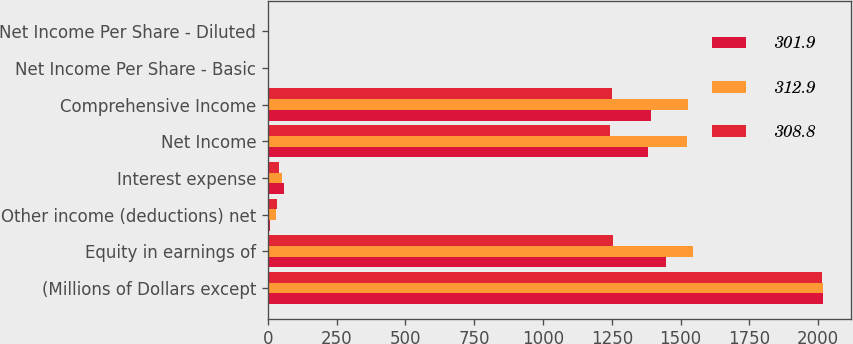<chart> <loc_0><loc_0><loc_500><loc_500><stacked_bar_chart><ecel><fcel>(Millions of Dollars except<fcel>Equity in earnings of<fcel>Other income (deductions) net<fcel>Interest expense<fcel>Net Income<fcel>Comprehensive Income<fcel>Net Income Per Share - Basic<fcel>Net Income Per Share - Diluted<nl><fcel>301.9<fcel>2018<fcel>1447<fcel>6<fcel>59<fcel>1382<fcel>1392<fcel>4.43<fcel>4.42<nl><fcel>312.9<fcel>2017<fcel>1544<fcel>31<fcel>50<fcel>1525<fcel>1526<fcel>4.97<fcel>4.94<nl><fcel>308.8<fcel>2016<fcel>1254<fcel>32<fcel>41<fcel>1245<fcel>1252<fcel>4.15<fcel>4.12<nl></chart> 